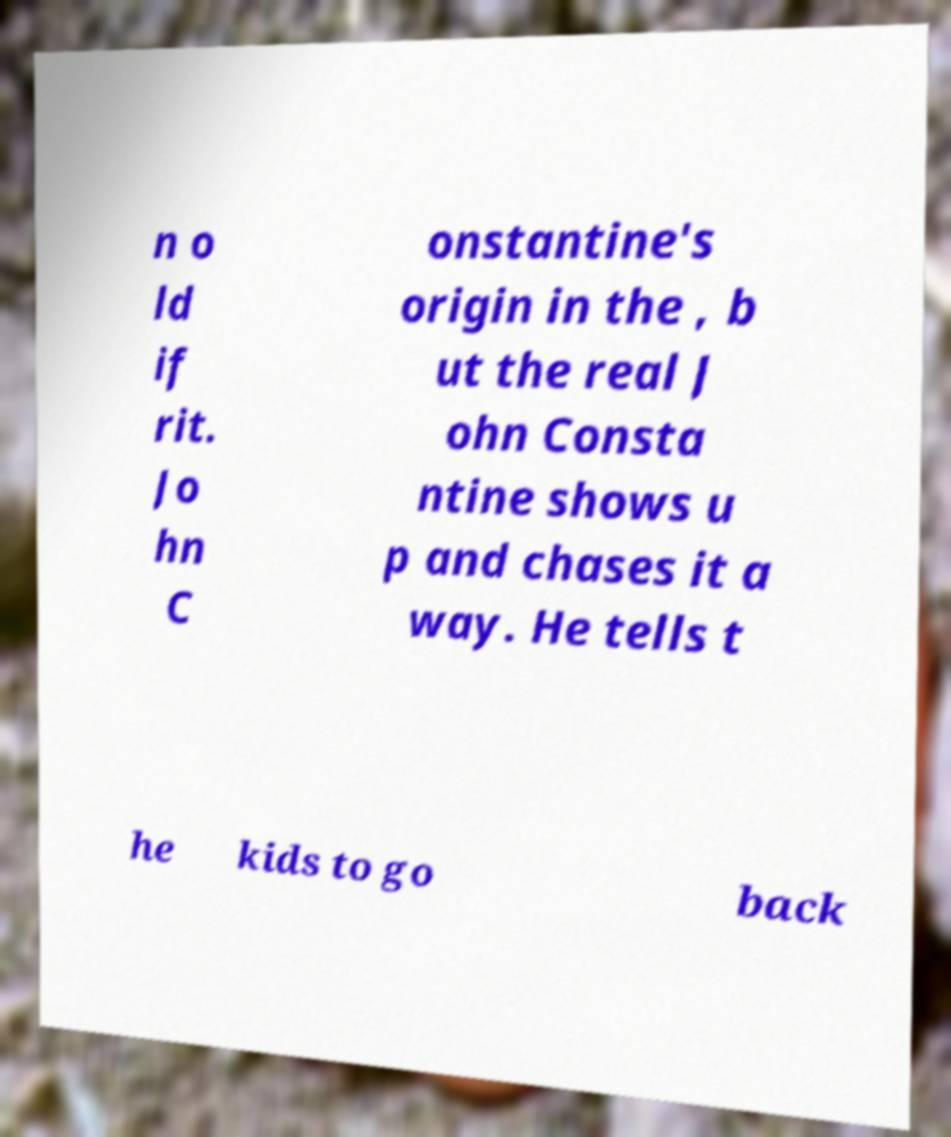Please identify and transcribe the text found in this image. n o ld if rit. Jo hn C onstantine's origin in the , b ut the real J ohn Consta ntine shows u p and chases it a way. He tells t he kids to go back 